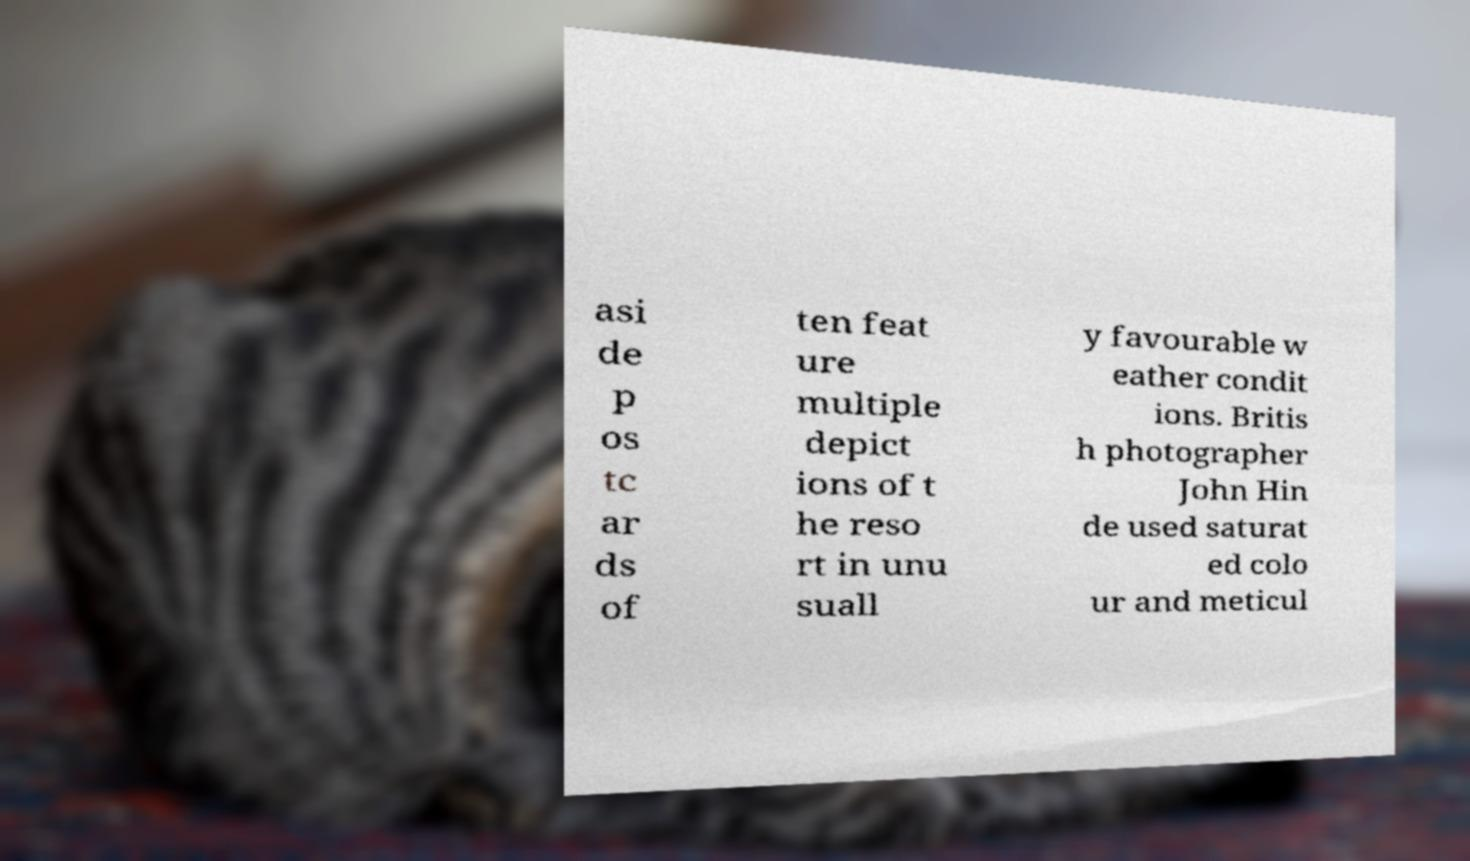Could you assist in decoding the text presented in this image and type it out clearly? asi de p os tc ar ds of ten feat ure multiple depict ions of t he reso rt in unu suall y favourable w eather condit ions. Britis h photographer John Hin de used saturat ed colo ur and meticul 